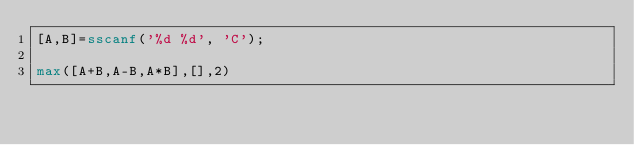<code> <loc_0><loc_0><loc_500><loc_500><_Octave_>[A,B]=sscanf('%d %d', 'C');

max([A+B,A-B,A*B],[],2)</code> 